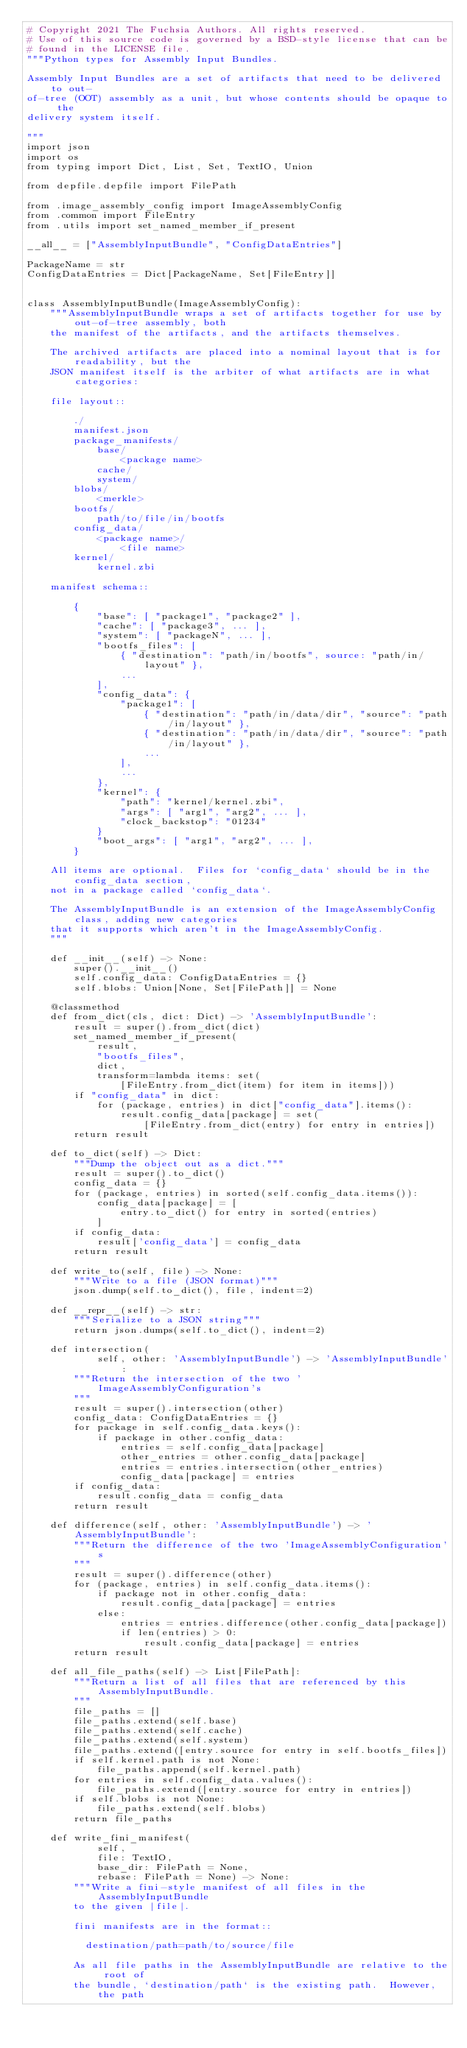Convert code to text. <code><loc_0><loc_0><loc_500><loc_500><_Python_># Copyright 2021 The Fuchsia Authors. All rights reserved.
# Use of this source code is governed by a BSD-style license that can be
# found in the LICENSE file.
"""Python types for Assembly Input Bundles.

Assembly Input Bundles are a set of artifacts that need to be delivered to out-
of-tree (OOT) assembly as a unit, but whose contents should be opaque to the
delivery system itself.

"""
import json
import os
from typing import Dict, List, Set, TextIO, Union

from depfile.depfile import FilePath

from .image_assembly_config import ImageAssemblyConfig
from .common import FileEntry
from .utils import set_named_member_if_present

__all__ = ["AssemblyInputBundle", "ConfigDataEntries"]

PackageName = str
ConfigDataEntries = Dict[PackageName, Set[FileEntry]]


class AssemblyInputBundle(ImageAssemblyConfig):
    """AssemblyInputBundle wraps a set of artifacts together for use by out-of-tree assembly, both
    the manifest of the artifacts, and the artifacts themselves.

    The archived artifacts are placed into a nominal layout that is for readability, but the
    JSON manifest itself is the arbiter of what artifacts are in what categories:

    file layout::

        ./
        manifest.json
        package_manifests/
            base/
                <package name>
            cache/
            system/
        blobs/
            <merkle>
        bootfs/
            path/to/file/in/bootfs
        config_data/
            <package name>/
                <file name>
        kernel/
            kernel.zbi

    manifest schema::

        {
            "base": [ "package1", "package2" ],
            "cache": [ "package3", ... ],
            "system": [ "packageN", ... ],
            "bootfs_files": [
                { "destination": "path/in/bootfs", source: "path/in/layout" },
                ...
            ],
            "config_data": {
                "package1": [
                    { "destination": "path/in/data/dir", "source": "path/in/layout" },
                    { "destination": "path/in/data/dir", "source": "path/in/layout" },
                    ...
                ],
                ...
            },
            "kernel": {
                "path": "kernel/kernel.zbi",
                "args": [ "arg1", "arg2", ... ],
                "clock_backstop": "01234"
            }
            "boot_args": [ "arg1", "arg2", ... ],
        }

    All items are optional.  Files for `config_data` should be in the config_data section,
    not in a package called `config_data`.

    The AssemblyInputBundle is an extension of the ImageAssemblyConfig class, adding new categories
    that it supports which aren't in the ImageAssemblyConfig.
    """

    def __init__(self) -> None:
        super().__init__()
        self.config_data: ConfigDataEntries = {}
        self.blobs: Union[None, Set[FilePath]] = None

    @classmethod
    def from_dict(cls, dict: Dict) -> 'AssemblyInputBundle':
        result = super().from_dict(dict)
        set_named_member_if_present(
            result,
            "bootfs_files",
            dict,
            transform=lambda items: set(
                [FileEntry.from_dict(item) for item in items]))
        if "config_data" in dict:
            for (package, entries) in dict["config_data"].items():
                result.config_data[package] = set(
                    [FileEntry.from_dict(entry) for entry in entries])
        return result

    def to_dict(self) -> Dict:
        """Dump the object out as a dict."""
        result = super().to_dict()
        config_data = {}
        for (package, entries) in sorted(self.config_data.items()):
            config_data[package] = [
                entry.to_dict() for entry in sorted(entries)
            ]
        if config_data:
            result['config_data'] = config_data
        return result

    def write_to(self, file) -> None:
        """Write to a file (JSON format)"""
        json.dump(self.to_dict(), file, indent=2)

    def __repr__(self) -> str:
        """Serialize to a JSON string"""
        return json.dumps(self.to_dict(), indent=2)

    def intersection(
            self, other: 'AssemblyInputBundle') -> 'AssemblyInputBundle':
        """Return the intersection of the two 'ImageAssemblyConfiguration's
        """
        result = super().intersection(other)
        config_data: ConfigDataEntries = {}
        for package in self.config_data.keys():
            if package in other.config_data:
                entries = self.config_data[package]
                other_entries = other.config_data[package]
                entries = entries.intersection(other_entries)
                config_data[package] = entries
        if config_data:
            result.config_data = config_data
        return result

    def difference(self, other: 'AssemblyInputBundle') -> 'AssemblyInputBundle':
        """Return the difference of the two 'ImageAssemblyConfiguration's
        """
        result = super().difference(other)
        for (package, entries) in self.config_data.items():
            if package not in other.config_data:
                result.config_data[package] = entries
            else:
                entries = entries.difference(other.config_data[package])
                if len(entries) > 0:
                    result.config_data[package] = entries
        return result

    def all_file_paths(self) -> List[FilePath]:
        """Return a list of all files that are referenced by this AssemblyInputBundle.
        """
        file_paths = []
        file_paths.extend(self.base)
        file_paths.extend(self.cache)
        file_paths.extend(self.system)
        file_paths.extend([entry.source for entry in self.bootfs_files])
        if self.kernel.path is not None:
            file_paths.append(self.kernel.path)
        for entries in self.config_data.values():
            file_paths.extend([entry.source for entry in entries])
        if self.blobs is not None:
            file_paths.extend(self.blobs)
        return file_paths

    def write_fini_manifest(
            self,
            file: TextIO,
            base_dir: FilePath = None,
            rebase: FilePath = None) -> None:
        """Write a fini-style manifest of all files in the AssemblyInputBundle
        to the given |file|.

        fini manifests are in the format::

          destination/path=path/to/source/file

        As all file paths in the AssemblyInputBundle are relative to the root of
        the bundle, `destination/path` is the existing path.  However, the path</code> 